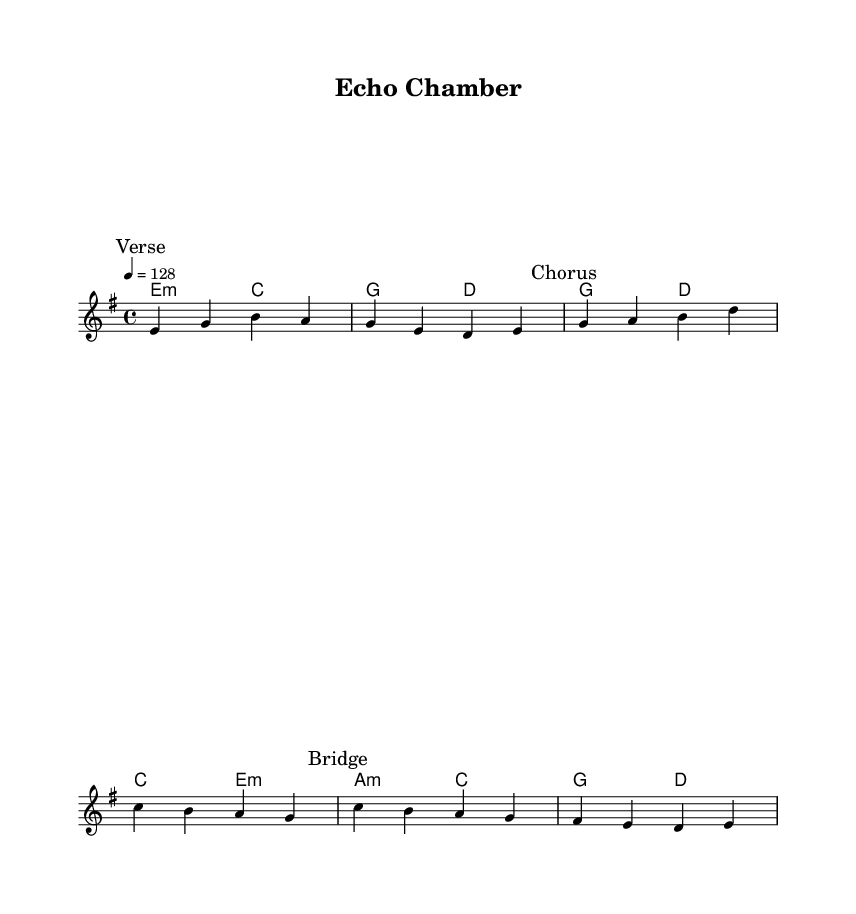What is the key signature of this music? The key signature is E minor, which has one sharp (F#). This can be seen at the beginning of the staff where the key signature is indicated.
Answer: E minor What is the time signature of this piece? The time signature is 4/4, which is shown at the beginning of the score. This means there are four beats in each measure and the quarter note gets one beat.
Answer: 4/4 What is the tempo marking for this piece? The tempo marking is indicated as "4 = 128," meaning that there are 128 beats per minute. This is shown at the beginning after the time signature.
Answer: 128 Which section has the lyrics "Break free from the nar -- ra -- tive"? This line appears in the "Bridge" section of the song, as indicated by the marking in the music. The lyrics are connected to the melody in this specific part of the song.
Answer: Bridge How many measures are in the verse section? The verse section consists of two measures, as indicated in the melody lines where the verse marking occurs. The counts of measures can be determined visually by the placement of the bar lines.
Answer: 2 What is the first chord played in the verse section? The first chord in the verse section is E minor, which is indicated in the harmonies part where the chord is displayed on the first beat of the first measure.
Answer: E minor What does the term "Echo Chamber" refer to in the context of this song? "Echo Chamber" refers to the chorus and thematic idea, suggesting the repetition and amplification of certain narratives or opinions in the media, creating a feedback loop that shapes public perception. This term relates directly to the song's critique of media bias.
Answer: Critique of media bias 